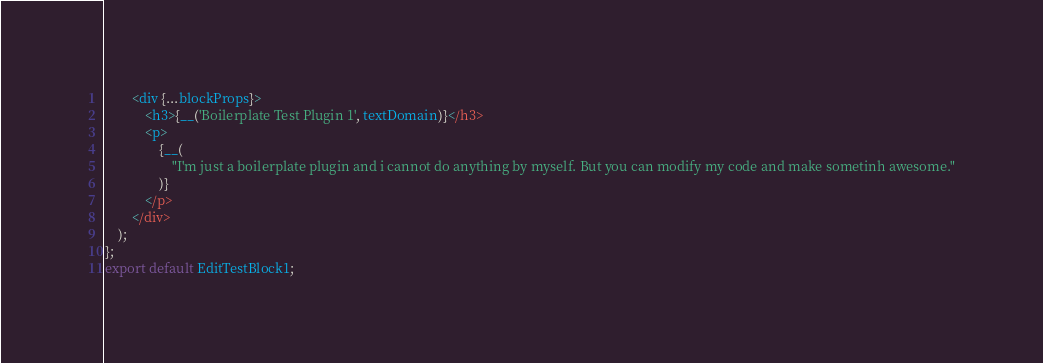<code> <loc_0><loc_0><loc_500><loc_500><_JavaScript_>		<div {...blockProps}>
			<h3>{__('Boilerplate Test Plugin 1', textDomain)}</h3>
			<p>
				{__(
					"I'm just a boilerplate plugin and i cannot do anything by myself. But you can modify my code and make sometinh awesome."
				)}
			</p>
		</div>
	);
};
export default EditTestBlock1;
</code> 